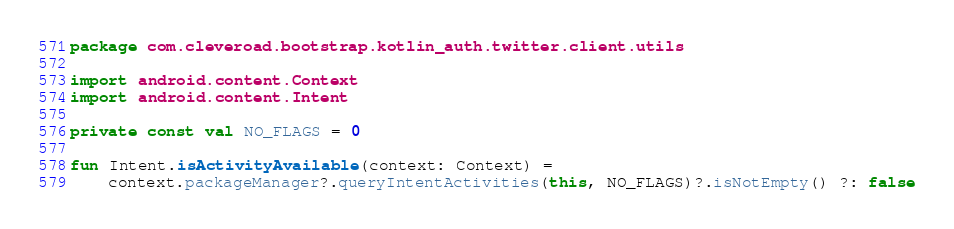Convert code to text. <code><loc_0><loc_0><loc_500><loc_500><_Kotlin_>package com.cleveroad.bootstrap.kotlin_auth.twitter.client.utils

import android.content.Context
import android.content.Intent

private const val NO_FLAGS = 0

fun Intent.isActivityAvailable(context: Context) =
    context.packageManager?.queryIntentActivities(this, NO_FLAGS)?.isNotEmpty() ?: false</code> 